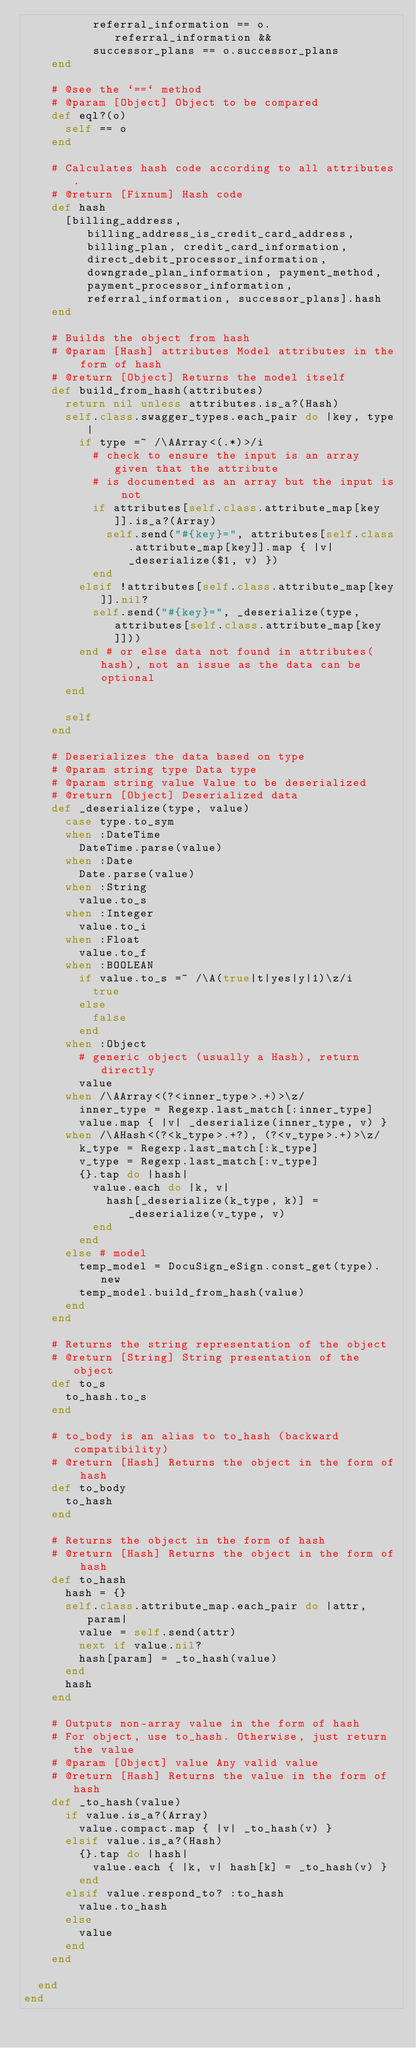<code> <loc_0><loc_0><loc_500><loc_500><_Ruby_>          referral_information == o.referral_information &&
          successor_plans == o.successor_plans
    end

    # @see the `==` method
    # @param [Object] Object to be compared
    def eql?(o)
      self == o
    end

    # Calculates hash code according to all attributes.
    # @return [Fixnum] Hash code
    def hash
      [billing_address, billing_address_is_credit_card_address, billing_plan, credit_card_information, direct_debit_processor_information, downgrade_plan_information, payment_method, payment_processor_information, referral_information, successor_plans].hash
    end

    # Builds the object from hash
    # @param [Hash] attributes Model attributes in the form of hash
    # @return [Object] Returns the model itself
    def build_from_hash(attributes)
      return nil unless attributes.is_a?(Hash)
      self.class.swagger_types.each_pair do |key, type|
        if type =~ /\AArray<(.*)>/i
          # check to ensure the input is an array given that the attribute
          # is documented as an array but the input is not
          if attributes[self.class.attribute_map[key]].is_a?(Array)
            self.send("#{key}=", attributes[self.class.attribute_map[key]].map { |v| _deserialize($1, v) })
          end
        elsif !attributes[self.class.attribute_map[key]].nil?
          self.send("#{key}=", _deserialize(type, attributes[self.class.attribute_map[key]]))
        end # or else data not found in attributes(hash), not an issue as the data can be optional
      end

      self
    end

    # Deserializes the data based on type
    # @param string type Data type
    # @param string value Value to be deserialized
    # @return [Object] Deserialized data
    def _deserialize(type, value)
      case type.to_sym
      when :DateTime
        DateTime.parse(value)
      when :Date
        Date.parse(value)
      when :String
        value.to_s
      when :Integer
        value.to_i
      when :Float
        value.to_f
      when :BOOLEAN
        if value.to_s =~ /\A(true|t|yes|y|1)\z/i
          true
        else
          false
        end
      when :Object
        # generic object (usually a Hash), return directly
        value
      when /\AArray<(?<inner_type>.+)>\z/
        inner_type = Regexp.last_match[:inner_type]
        value.map { |v| _deserialize(inner_type, v) }
      when /\AHash<(?<k_type>.+?), (?<v_type>.+)>\z/
        k_type = Regexp.last_match[:k_type]
        v_type = Regexp.last_match[:v_type]
        {}.tap do |hash|
          value.each do |k, v|
            hash[_deserialize(k_type, k)] = _deserialize(v_type, v)
          end
        end
      else # model
        temp_model = DocuSign_eSign.const_get(type).new
        temp_model.build_from_hash(value)
      end
    end

    # Returns the string representation of the object
    # @return [String] String presentation of the object
    def to_s
      to_hash.to_s
    end

    # to_body is an alias to to_hash (backward compatibility)
    # @return [Hash] Returns the object in the form of hash
    def to_body
      to_hash
    end

    # Returns the object in the form of hash
    # @return [Hash] Returns the object in the form of hash
    def to_hash
      hash = {}
      self.class.attribute_map.each_pair do |attr, param|
        value = self.send(attr)
        next if value.nil?
        hash[param] = _to_hash(value)
      end
      hash
    end

    # Outputs non-array value in the form of hash
    # For object, use to_hash. Otherwise, just return the value
    # @param [Object] value Any valid value
    # @return [Hash] Returns the value in the form of hash
    def _to_hash(value)
      if value.is_a?(Array)
        value.compact.map { |v| _to_hash(v) }
      elsif value.is_a?(Hash)
        {}.tap do |hash|
          value.each { |k, v| hash[k] = _to_hash(v) }
        end
      elsif value.respond_to? :to_hash
        value.to_hash
      else
        value
      end
    end

  end
end
</code> 